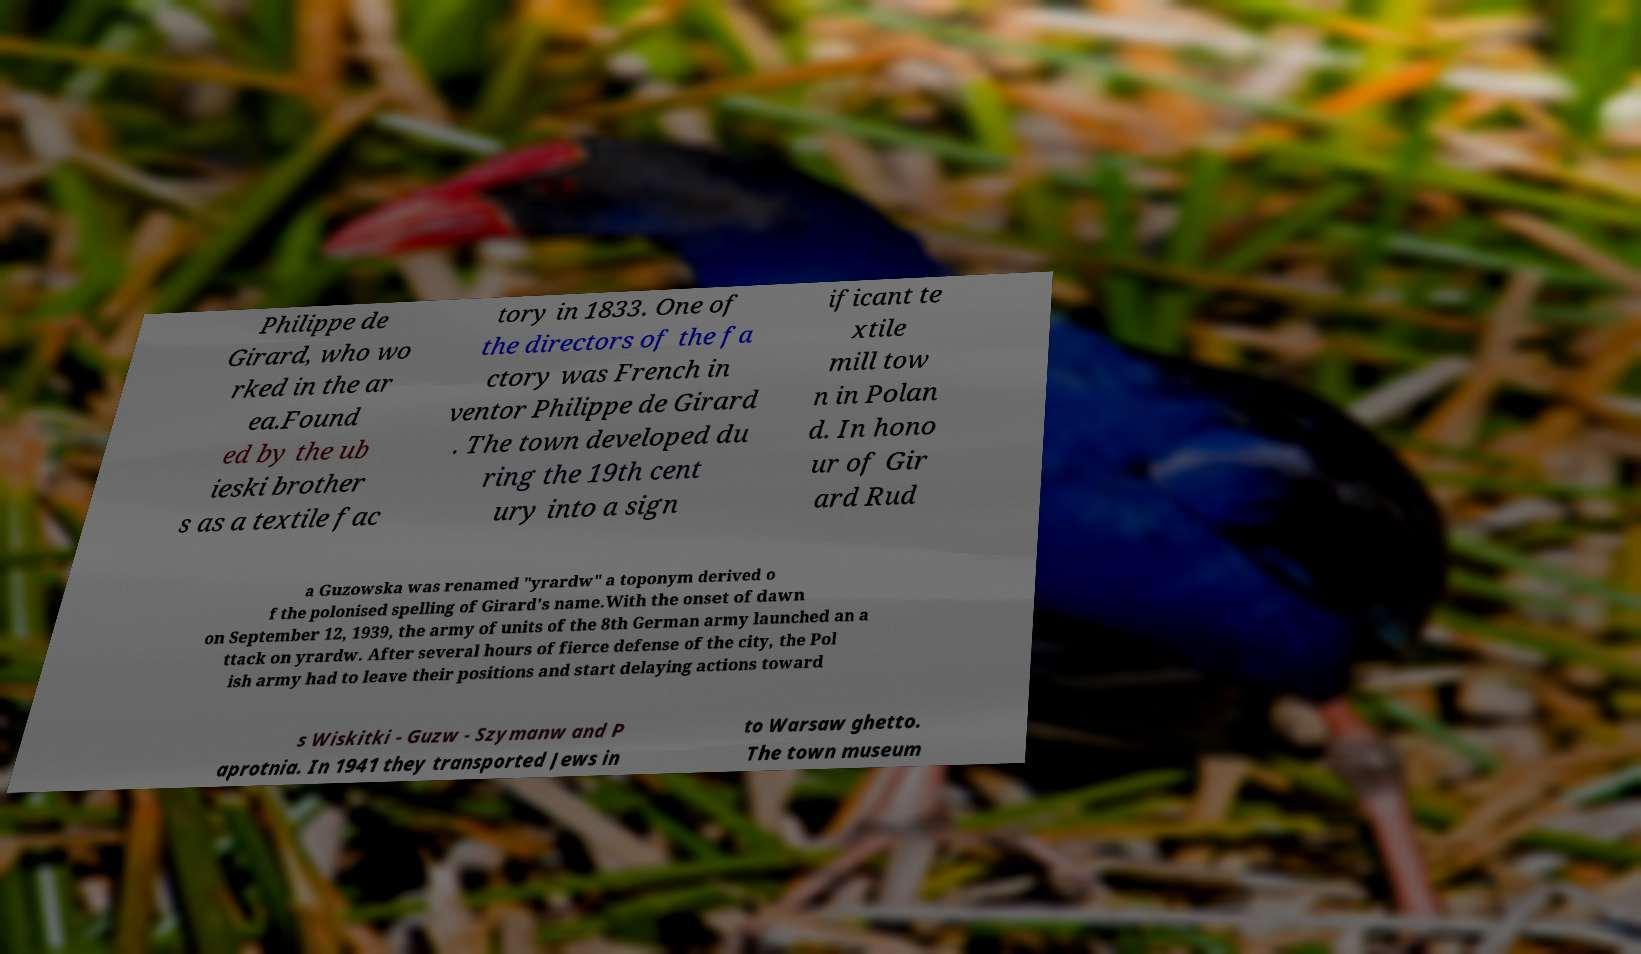Can you read and provide the text displayed in the image?This photo seems to have some interesting text. Can you extract and type it out for me? Philippe de Girard, who wo rked in the ar ea.Found ed by the ub ieski brother s as a textile fac tory in 1833. One of the directors of the fa ctory was French in ventor Philippe de Girard . The town developed du ring the 19th cent ury into a sign ificant te xtile mill tow n in Polan d. In hono ur of Gir ard Rud a Guzowska was renamed "yrardw" a toponym derived o f the polonised spelling of Girard's name.With the onset of dawn on September 12, 1939, the army of units of the 8th German army launched an a ttack on yrardw. After several hours of fierce defense of the city, the Pol ish army had to leave their positions and start delaying actions toward s Wiskitki - Guzw - Szymanw and P aprotnia. In 1941 they transported Jews in to Warsaw ghetto. The town museum 